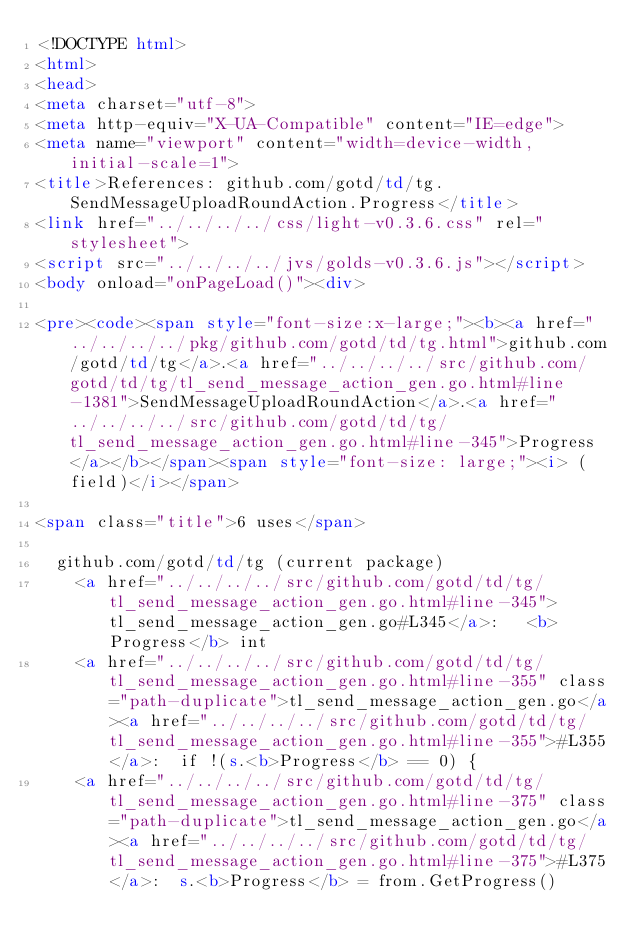Convert code to text. <code><loc_0><loc_0><loc_500><loc_500><_HTML_><!DOCTYPE html>
<html>
<head>
<meta charset="utf-8">
<meta http-equiv="X-UA-Compatible" content="IE=edge">
<meta name="viewport" content="width=device-width, initial-scale=1">
<title>References: github.com/gotd/td/tg.SendMessageUploadRoundAction.Progress</title>
<link href="../../../../css/light-v0.3.6.css" rel="stylesheet">
<script src="../../../../jvs/golds-v0.3.6.js"></script>
<body onload="onPageLoad()"><div>

<pre><code><span style="font-size:x-large;"><b><a href="../../../../pkg/github.com/gotd/td/tg.html">github.com/gotd/td/tg</a>.<a href="../../../../src/github.com/gotd/td/tg/tl_send_message_action_gen.go.html#line-1381">SendMessageUploadRoundAction</a>.<a href="../../../../src/github.com/gotd/td/tg/tl_send_message_action_gen.go.html#line-345">Progress</a></b></span><span style="font-size: large;"><i> (field)</i></span>

<span class="title">6 uses</span>

	github.com/gotd/td/tg (current package)
		<a href="../../../../src/github.com/gotd/td/tg/tl_send_message_action_gen.go.html#line-345">tl_send_message_action_gen.go#L345</a>: 	<b>Progress</b> int
		<a href="../../../../src/github.com/gotd/td/tg/tl_send_message_action_gen.go.html#line-355" class="path-duplicate">tl_send_message_action_gen.go</a><a href="../../../../src/github.com/gotd/td/tg/tl_send_message_action_gen.go.html#line-355">#L355</a>: 	if !(s.<b>Progress</b> == 0) {
		<a href="../../../../src/github.com/gotd/td/tg/tl_send_message_action_gen.go.html#line-375" class="path-duplicate">tl_send_message_action_gen.go</a><a href="../../../../src/github.com/gotd/td/tg/tl_send_message_action_gen.go.html#line-375">#L375</a>: 	s.<b>Progress</b> = from.GetProgress()</code> 